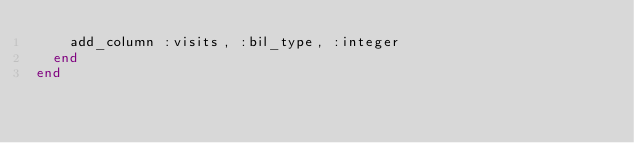<code> <loc_0><loc_0><loc_500><loc_500><_Ruby_>    add_column :visits, :bil_type, :integer
  end
end
</code> 